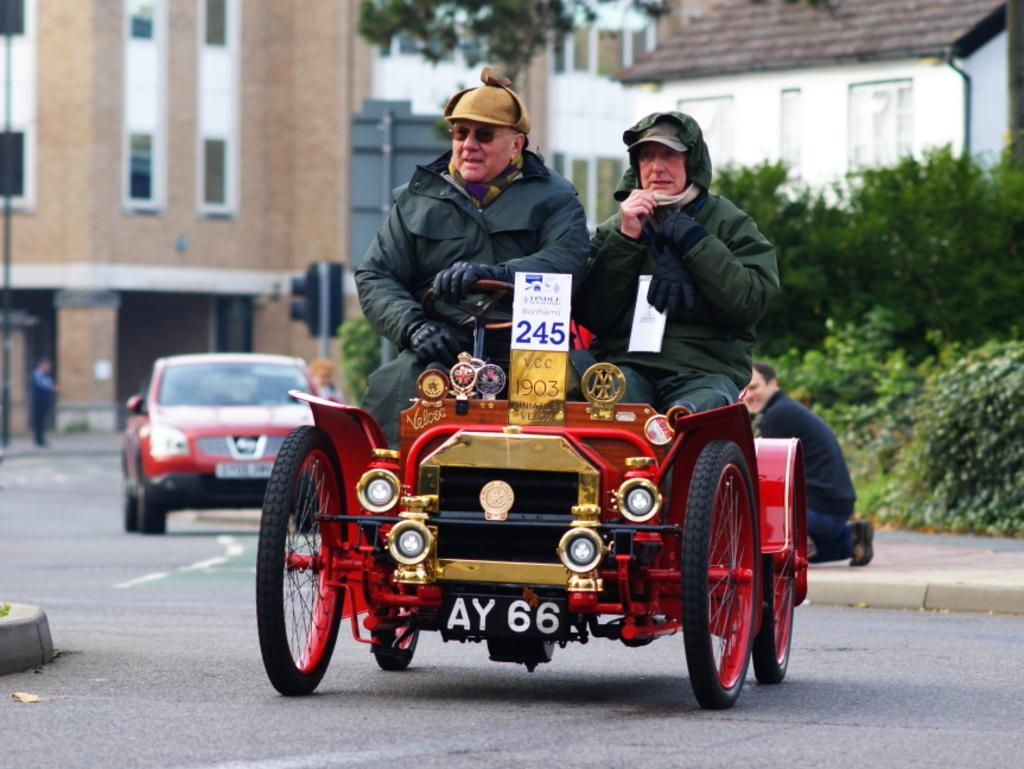How many people are in the image? There are two people in the image. What are the two people doing in the image? The two people are riding a four-wheeled vehicle. What can be seen in the background of the image? There is a car, trees, and at least one building visible in the background of the image. What type of gold jewelry is the person on the left wearing in the image? There is no gold jewelry visible on the person on the left in the image. What type of meat is being cooked on the grill in the background of the image? There is no grill or meat present in the image. 